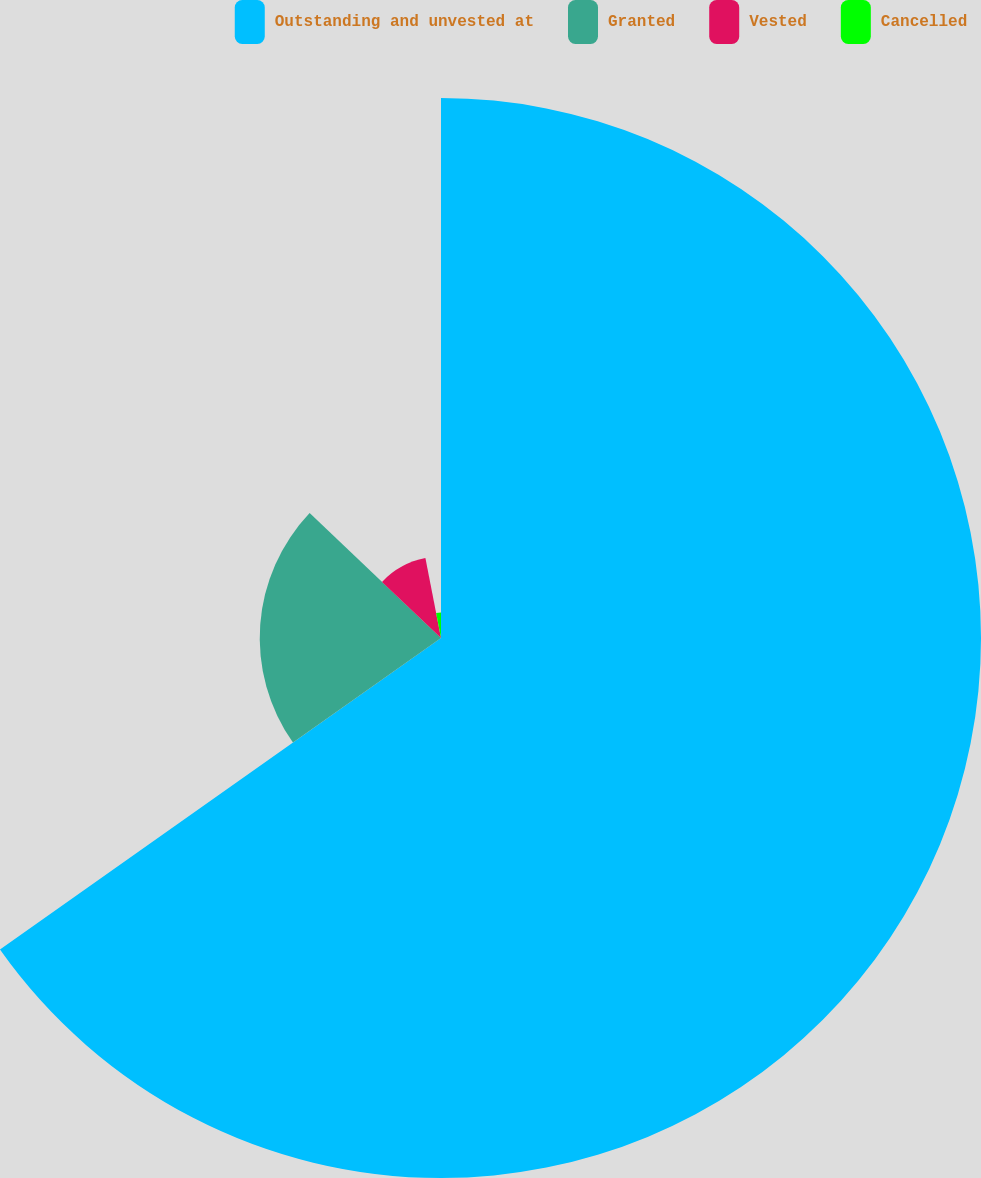<chart> <loc_0><loc_0><loc_500><loc_500><pie_chart><fcel>Outstanding and unvested at<fcel>Granted<fcel>Vested<fcel>Cancelled<nl><fcel>65.21%<fcel>21.89%<fcel>9.83%<fcel>3.07%<nl></chart> 